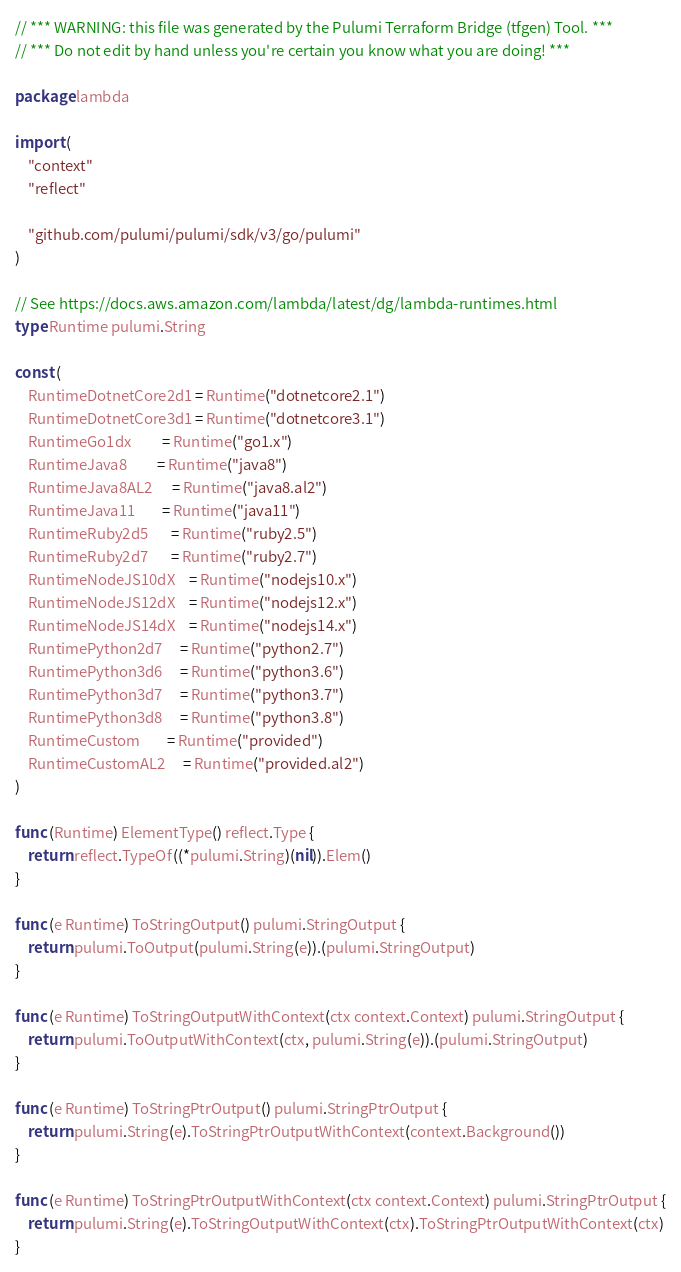Convert code to text. <code><loc_0><loc_0><loc_500><loc_500><_Go_>// *** WARNING: this file was generated by the Pulumi Terraform Bridge (tfgen) Tool. ***
// *** Do not edit by hand unless you're certain you know what you are doing! ***

package lambda

import (
	"context"
	"reflect"

	"github.com/pulumi/pulumi/sdk/v3/go/pulumi"
)

// See https://docs.aws.amazon.com/lambda/latest/dg/lambda-runtimes.html
type Runtime pulumi.String

const (
	RuntimeDotnetCore2d1 = Runtime("dotnetcore2.1")
	RuntimeDotnetCore3d1 = Runtime("dotnetcore3.1")
	RuntimeGo1dx         = Runtime("go1.x")
	RuntimeJava8         = Runtime("java8")
	RuntimeJava8AL2      = Runtime("java8.al2")
	RuntimeJava11        = Runtime("java11")
	RuntimeRuby2d5       = Runtime("ruby2.5")
	RuntimeRuby2d7       = Runtime("ruby2.7")
	RuntimeNodeJS10dX    = Runtime("nodejs10.x")
	RuntimeNodeJS12dX    = Runtime("nodejs12.x")
	RuntimeNodeJS14dX    = Runtime("nodejs14.x")
	RuntimePython2d7     = Runtime("python2.7")
	RuntimePython3d6     = Runtime("python3.6")
	RuntimePython3d7     = Runtime("python3.7")
	RuntimePython3d8     = Runtime("python3.8")
	RuntimeCustom        = Runtime("provided")
	RuntimeCustomAL2     = Runtime("provided.al2")
)

func (Runtime) ElementType() reflect.Type {
	return reflect.TypeOf((*pulumi.String)(nil)).Elem()
}

func (e Runtime) ToStringOutput() pulumi.StringOutput {
	return pulumi.ToOutput(pulumi.String(e)).(pulumi.StringOutput)
}

func (e Runtime) ToStringOutputWithContext(ctx context.Context) pulumi.StringOutput {
	return pulumi.ToOutputWithContext(ctx, pulumi.String(e)).(pulumi.StringOutput)
}

func (e Runtime) ToStringPtrOutput() pulumi.StringPtrOutput {
	return pulumi.String(e).ToStringPtrOutputWithContext(context.Background())
}

func (e Runtime) ToStringPtrOutputWithContext(ctx context.Context) pulumi.StringPtrOutput {
	return pulumi.String(e).ToStringOutputWithContext(ctx).ToStringPtrOutputWithContext(ctx)
}
</code> 